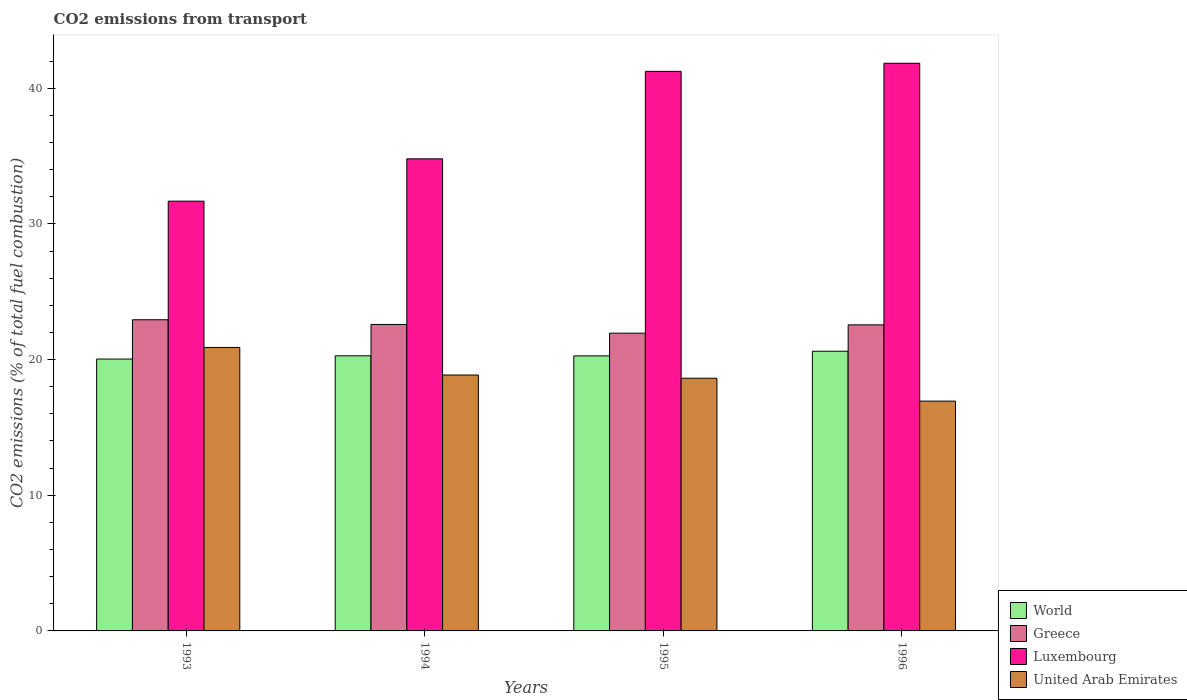Are the number of bars on each tick of the X-axis equal?
Make the answer very short. Yes. How many bars are there on the 4th tick from the left?
Give a very brief answer. 4. In how many cases, is the number of bars for a given year not equal to the number of legend labels?
Give a very brief answer. 0. What is the total CO2 emitted in World in 1993?
Give a very brief answer. 20.04. Across all years, what is the maximum total CO2 emitted in Greece?
Provide a succinct answer. 22.94. Across all years, what is the minimum total CO2 emitted in Luxembourg?
Keep it short and to the point. 31.68. In which year was the total CO2 emitted in World minimum?
Provide a short and direct response. 1993. What is the total total CO2 emitted in Greece in the graph?
Your answer should be compact. 90.03. What is the difference between the total CO2 emitted in World in 1994 and that in 1996?
Keep it short and to the point. -0.34. What is the difference between the total CO2 emitted in United Arab Emirates in 1993 and the total CO2 emitted in Greece in 1995?
Offer a very short reply. -1.06. What is the average total CO2 emitted in Luxembourg per year?
Your response must be concise. 37.39. In the year 1995, what is the difference between the total CO2 emitted in Luxembourg and total CO2 emitted in United Arab Emirates?
Your answer should be very brief. 22.62. What is the ratio of the total CO2 emitted in Greece in 1995 to that in 1996?
Provide a succinct answer. 0.97. Is the total CO2 emitted in Luxembourg in 1993 less than that in 1994?
Provide a succinct answer. Yes. What is the difference between the highest and the second highest total CO2 emitted in World?
Provide a succinct answer. 0.34. What is the difference between the highest and the lowest total CO2 emitted in Luxembourg?
Your response must be concise. 10.16. In how many years, is the total CO2 emitted in Greece greater than the average total CO2 emitted in Greece taken over all years?
Keep it short and to the point. 3. Is the sum of the total CO2 emitted in World in 1994 and 1995 greater than the maximum total CO2 emitted in Greece across all years?
Make the answer very short. Yes. What does the 2nd bar from the right in 1995 represents?
Keep it short and to the point. Luxembourg. How many bars are there?
Give a very brief answer. 16. Are all the bars in the graph horizontal?
Your answer should be very brief. No. How many years are there in the graph?
Provide a short and direct response. 4. Are the values on the major ticks of Y-axis written in scientific E-notation?
Your answer should be very brief. No. Does the graph contain any zero values?
Provide a short and direct response. No. Where does the legend appear in the graph?
Provide a short and direct response. Bottom right. What is the title of the graph?
Give a very brief answer. CO2 emissions from transport. Does "Romania" appear as one of the legend labels in the graph?
Your response must be concise. No. What is the label or title of the X-axis?
Make the answer very short. Years. What is the label or title of the Y-axis?
Provide a succinct answer. CO2 emissions (% of total fuel combustion). What is the CO2 emissions (% of total fuel combustion) in World in 1993?
Offer a very short reply. 20.04. What is the CO2 emissions (% of total fuel combustion) of Greece in 1993?
Make the answer very short. 22.94. What is the CO2 emissions (% of total fuel combustion) in Luxembourg in 1993?
Provide a succinct answer. 31.68. What is the CO2 emissions (% of total fuel combustion) in United Arab Emirates in 1993?
Your answer should be compact. 20.89. What is the CO2 emissions (% of total fuel combustion) in World in 1994?
Make the answer very short. 20.28. What is the CO2 emissions (% of total fuel combustion) in Greece in 1994?
Give a very brief answer. 22.59. What is the CO2 emissions (% of total fuel combustion) of Luxembourg in 1994?
Make the answer very short. 34.8. What is the CO2 emissions (% of total fuel combustion) in United Arab Emirates in 1994?
Provide a succinct answer. 18.86. What is the CO2 emissions (% of total fuel combustion) in World in 1995?
Keep it short and to the point. 20.27. What is the CO2 emissions (% of total fuel combustion) of Greece in 1995?
Give a very brief answer. 21.95. What is the CO2 emissions (% of total fuel combustion) of Luxembourg in 1995?
Offer a terse response. 41.24. What is the CO2 emissions (% of total fuel combustion) in United Arab Emirates in 1995?
Offer a terse response. 18.62. What is the CO2 emissions (% of total fuel combustion) in World in 1996?
Offer a terse response. 20.61. What is the CO2 emissions (% of total fuel combustion) in Greece in 1996?
Ensure brevity in your answer.  22.56. What is the CO2 emissions (% of total fuel combustion) in Luxembourg in 1996?
Offer a very short reply. 41.84. What is the CO2 emissions (% of total fuel combustion) in United Arab Emirates in 1996?
Offer a terse response. 16.94. Across all years, what is the maximum CO2 emissions (% of total fuel combustion) in World?
Give a very brief answer. 20.61. Across all years, what is the maximum CO2 emissions (% of total fuel combustion) in Greece?
Ensure brevity in your answer.  22.94. Across all years, what is the maximum CO2 emissions (% of total fuel combustion) of Luxembourg?
Provide a short and direct response. 41.84. Across all years, what is the maximum CO2 emissions (% of total fuel combustion) of United Arab Emirates?
Make the answer very short. 20.89. Across all years, what is the minimum CO2 emissions (% of total fuel combustion) in World?
Ensure brevity in your answer.  20.04. Across all years, what is the minimum CO2 emissions (% of total fuel combustion) of Greece?
Make the answer very short. 21.95. Across all years, what is the minimum CO2 emissions (% of total fuel combustion) of Luxembourg?
Offer a very short reply. 31.68. Across all years, what is the minimum CO2 emissions (% of total fuel combustion) of United Arab Emirates?
Make the answer very short. 16.94. What is the total CO2 emissions (% of total fuel combustion) in World in the graph?
Make the answer very short. 81.2. What is the total CO2 emissions (% of total fuel combustion) of Greece in the graph?
Keep it short and to the point. 90.03. What is the total CO2 emissions (% of total fuel combustion) of Luxembourg in the graph?
Ensure brevity in your answer.  149.55. What is the total CO2 emissions (% of total fuel combustion) in United Arab Emirates in the graph?
Give a very brief answer. 75.31. What is the difference between the CO2 emissions (% of total fuel combustion) in World in 1993 and that in 1994?
Offer a very short reply. -0.24. What is the difference between the CO2 emissions (% of total fuel combustion) of Greece in 1993 and that in 1994?
Your answer should be very brief. 0.35. What is the difference between the CO2 emissions (% of total fuel combustion) in Luxembourg in 1993 and that in 1994?
Make the answer very short. -3.12. What is the difference between the CO2 emissions (% of total fuel combustion) of United Arab Emirates in 1993 and that in 1994?
Your answer should be very brief. 2.03. What is the difference between the CO2 emissions (% of total fuel combustion) of World in 1993 and that in 1995?
Provide a succinct answer. -0.23. What is the difference between the CO2 emissions (% of total fuel combustion) in Greece in 1993 and that in 1995?
Ensure brevity in your answer.  0.99. What is the difference between the CO2 emissions (% of total fuel combustion) in Luxembourg in 1993 and that in 1995?
Your answer should be compact. -9.57. What is the difference between the CO2 emissions (% of total fuel combustion) in United Arab Emirates in 1993 and that in 1995?
Provide a succinct answer. 2.27. What is the difference between the CO2 emissions (% of total fuel combustion) in World in 1993 and that in 1996?
Offer a terse response. -0.58. What is the difference between the CO2 emissions (% of total fuel combustion) of Greece in 1993 and that in 1996?
Your answer should be compact. 0.38. What is the difference between the CO2 emissions (% of total fuel combustion) of Luxembourg in 1993 and that in 1996?
Ensure brevity in your answer.  -10.16. What is the difference between the CO2 emissions (% of total fuel combustion) in United Arab Emirates in 1993 and that in 1996?
Provide a succinct answer. 3.95. What is the difference between the CO2 emissions (% of total fuel combustion) in World in 1994 and that in 1995?
Your response must be concise. 0.01. What is the difference between the CO2 emissions (% of total fuel combustion) in Greece in 1994 and that in 1995?
Provide a succinct answer. 0.64. What is the difference between the CO2 emissions (% of total fuel combustion) of Luxembourg in 1994 and that in 1995?
Your response must be concise. -6.45. What is the difference between the CO2 emissions (% of total fuel combustion) of United Arab Emirates in 1994 and that in 1995?
Give a very brief answer. 0.24. What is the difference between the CO2 emissions (% of total fuel combustion) of World in 1994 and that in 1996?
Your response must be concise. -0.34. What is the difference between the CO2 emissions (% of total fuel combustion) in Greece in 1994 and that in 1996?
Provide a succinct answer. 0.03. What is the difference between the CO2 emissions (% of total fuel combustion) in Luxembourg in 1994 and that in 1996?
Your answer should be very brief. -7.04. What is the difference between the CO2 emissions (% of total fuel combustion) of United Arab Emirates in 1994 and that in 1996?
Provide a succinct answer. 1.92. What is the difference between the CO2 emissions (% of total fuel combustion) in World in 1995 and that in 1996?
Ensure brevity in your answer.  -0.34. What is the difference between the CO2 emissions (% of total fuel combustion) of Greece in 1995 and that in 1996?
Give a very brief answer. -0.61. What is the difference between the CO2 emissions (% of total fuel combustion) of Luxembourg in 1995 and that in 1996?
Keep it short and to the point. -0.6. What is the difference between the CO2 emissions (% of total fuel combustion) in United Arab Emirates in 1995 and that in 1996?
Provide a short and direct response. 1.69. What is the difference between the CO2 emissions (% of total fuel combustion) in World in 1993 and the CO2 emissions (% of total fuel combustion) in Greece in 1994?
Your response must be concise. -2.55. What is the difference between the CO2 emissions (% of total fuel combustion) of World in 1993 and the CO2 emissions (% of total fuel combustion) of Luxembourg in 1994?
Give a very brief answer. -14.76. What is the difference between the CO2 emissions (% of total fuel combustion) in World in 1993 and the CO2 emissions (% of total fuel combustion) in United Arab Emirates in 1994?
Provide a succinct answer. 1.18. What is the difference between the CO2 emissions (% of total fuel combustion) of Greece in 1993 and the CO2 emissions (% of total fuel combustion) of Luxembourg in 1994?
Ensure brevity in your answer.  -11.86. What is the difference between the CO2 emissions (% of total fuel combustion) of Greece in 1993 and the CO2 emissions (% of total fuel combustion) of United Arab Emirates in 1994?
Make the answer very short. 4.07. What is the difference between the CO2 emissions (% of total fuel combustion) in Luxembourg in 1993 and the CO2 emissions (% of total fuel combustion) in United Arab Emirates in 1994?
Ensure brevity in your answer.  12.81. What is the difference between the CO2 emissions (% of total fuel combustion) of World in 1993 and the CO2 emissions (% of total fuel combustion) of Greece in 1995?
Provide a short and direct response. -1.91. What is the difference between the CO2 emissions (% of total fuel combustion) in World in 1993 and the CO2 emissions (% of total fuel combustion) in Luxembourg in 1995?
Your answer should be compact. -21.2. What is the difference between the CO2 emissions (% of total fuel combustion) in World in 1993 and the CO2 emissions (% of total fuel combustion) in United Arab Emirates in 1995?
Make the answer very short. 1.41. What is the difference between the CO2 emissions (% of total fuel combustion) in Greece in 1993 and the CO2 emissions (% of total fuel combustion) in Luxembourg in 1995?
Make the answer very short. -18.31. What is the difference between the CO2 emissions (% of total fuel combustion) of Greece in 1993 and the CO2 emissions (% of total fuel combustion) of United Arab Emirates in 1995?
Offer a very short reply. 4.31. What is the difference between the CO2 emissions (% of total fuel combustion) in Luxembourg in 1993 and the CO2 emissions (% of total fuel combustion) in United Arab Emirates in 1995?
Keep it short and to the point. 13.05. What is the difference between the CO2 emissions (% of total fuel combustion) in World in 1993 and the CO2 emissions (% of total fuel combustion) in Greece in 1996?
Your response must be concise. -2.52. What is the difference between the CO2 emissions (% of total fuel combustion) in World in 1993 and the CO2 emissions (% of total fuel combustion) in Luxembourg in 1996?
Make the answer very short. -21.8. What is the difference between the CO2 emissions (% of total fuel combustion) of World in 1993 and the CO2 emissions (% of total fuel combustion) of United Arab Emirates in 1996?
Offer a very short reply. 3.1. What is the difference between the CO2 emissions (% of total fuel combustion) in Greece in 1993 and the CO2 emissions (% of total fuel combustion) in Luxembourg in 1996?
Give a very brief answer. -18.91. What is the difference between the CO2 emissions (% of total fuel combustion) of Greece in 1993 and the CO2 emissions (% of total fuel combustion) of United Arab Emirates in 1996?
Give a very brief answer. 6. What is the difference between the CO2 emissions (% of total fuel combustion) in Luxembourg in 1993 and the CO2 emissions (% of total fuel combustion) in United Arab Emirates in 1996?
Keep it short and to the point. 14.74. What is the difference between the CO2 emissions (% of total fuel combustion) in World in 1994 and the CO2 emissions (% of total fuel combustion) in Greece in 1995?
Make the answer very short. -1.67. What is the difference between the CO2 emissions (% of total fuel combustion) of World in 1994 and the CO2 emissions (% of total fuel combustion) of Luxembourg in 1995?
Offer a terse response. -20.96. What is the difference between the CO2 emissions (% of total fuel combustion) in World in 1994 and the CO2 emissions (% of total fuel combustion) in United Arab Emirates in 1995?
Your answer should be very brief. 1.65. What is the difference between the CO2 emissions (% of total fuel combustion) of Greece in 1994 and the CO2 emissions (% of total fuel combustion) of Luxembourg in 1995?
Make the answer very short. -18.65. What is the difference between the CO2 emissions (% of total fuel combustion) in Greece in 1994 and the CO2 emissions (% of total fuel combustion) in United Arab Emirates in 1995?
Offer a very short reply. 3.96. What is the difference between the CO2 emissions (% of total fuel combustion) in Luxembourg in 1994 and the CO2 emissions (% of total fuel combustion) in United Arab Emirates in 1995?
Offer a terse response. 16.17. What is the difference between the CO2 emissions (% of total fuel combustion) in World in 1994 and the CO2 emissions (% of total fuel combustion) in Greece in 1996?
Give a very brief answer. -2.28. What is the difference between the CO2 emissions (% of total fuel combustion) of World in 1994 and the CO2 emissions (% of total fuel combustion) of Luxembourg in 1996?
Your answer should be compact. -21.56. What is the difference between the CO2 emissions (% of total fuel combustion) in World in 1994 and the CO2 emissions (% of total fuel combustion) in United Arab Emirates in 1996?
Make the answer very short. 3.34. What is the difference between the CO2 emissions (% of total fuel combustion) of Greece in 1994 and the CO2 emissions (% of total fuel combustion) of Luxembourg in 1996?
Keep it short and to the point. -19.25. What is the difference between the CO2 emissions (% of total fuel combustion) in Greece in 1994 and the CO2 emissions (% of total fuel combustion) in United Arab Emirates in 1996?
Your answer should be very brief. 5.65. What is the difference between the CO2 emissions (% of total fuel combustion) in Luxembourg in 1994 and the CO2 emissions (% of total fuel combustion) in United Arab Emirates in 1996?
Keep it short and to the point. 17.86. What is the difference between the CO2 emissions (% of total fuel combustion) of World in 1995 and the CO2 emissions (% of total fuel combustion) of Greece in 1996?
Offer a very short reply. -2.29. What is the difference between the CO2 emissions (% of total fuel combustion) in World in 1995 and the CO2 emissions (% of total fuel combustion) in Luxembourg in 1996?
Offer a very short reply. -21.57. What is the difference between the CO2 emissions (% of total fuel combustion) of World in 1995 and the CO2 emissions (% of total fuel combustion) of United Arab Emirates in 1996?
Your answer should be compact. 3.33. What is the difference between the CO2 emissions (% of total fuel combustion) of Greece in 1995 and the CO2 emissions (% of total fuel combustion) of Luxembourg in 1996?
Your answer should be very brief. -19.89. What is the difference between the CO2 emissions (% of total fuel combustion) in Greece in 1995 and the CO2 emissions (% of total fuel combustion) in United Arab Emirates in 1996?
Provide a succinct answer. 5.01. What is the difference between the CO2 emissions (% of total fuel combustion) of Luxembourg in 1995 and the CO2 emissions (% of total fuel combustion) of United Arab Emirates in 1996?
Offer a very short reply. 24.3. What is the average CO2 emissions (% of total fuel combustion) in World per year?
Your answer should be compact. 20.3. What is the average CO2 emissions (% of total fuel combustion) in Greece per year?
Your response must be concise. 22.51. What is the average CO2 emissions (% of total fuel combustion) of Luxembourg per year?
Provide a succinct answer. 37.39. What is the average CO2 emissions (% of total fuel combustion) of United Arab Emirates per year?
Ensure brevity in your answer.  18.83. In the year 1993, what is the difference between the CO2 emissions (% of total fuel combustion) in World and CO2 emissions (% of total fuel combustion) in Greece?
Offer a very short reply. -2.9. In the year 1993, what is the difference between the CO2 emissions (% of total fuel combustion) of World and CO2 emissions (% of total fuel combustion) of Luxembourg?
Keep it short and to the point. -11.64. In the year 1993, what is the difference between the CO2 emissions (% of total fuel combustion) in World and CO2 emissions (% of total fuel combustion) in United Arab Emirates?
Your answer should be compact. -0.85. In the year 1993, what is the difference between the CO2 emissions (% of total fuel combustion) of Greece and CO2 emissions (% of total fuel combustion) of Luxembourg?
Your answer should be very brief. -8.74. In the year 1993, what is the difference between the CO2 emissions (% of total fuel combustion) of Greece and CO2 emissions (% of total fuel combustion) of United Arab Emirates?
Ensure brevity in your answer.  2.04. In the year 1993, what is the difference between the CO2 emissions (% of total fuel combustion) in Luxembourg and CO2 emissions (% of total fuel combustion) in United Arab Emirates?
Offer a terse response. 10.78. In the year 1994, what is the difference between the CO2 emissions (% of total fuel combustion) in World and CO2 emissions (% of total fuel combustion) in Greece?
Give a very brief answer. -2.31. In the year 1994, what is the difference between the CO2 emissions (% of total fuel combustion) of World and CO2 emissions (% of total fuel combustion) of Luxembourg?
Offer a very short reply. -14.52. In the year 1994, what is the difference between the CO2 emissions (% of total fuel combustion) of World and CO2 emissions (% of total fuel combustion) of United Arab Emirates?
Ensure brevity in your answer.  1.42. In the year 1994, what is the difference between the CO2 emissions (% of total fuel combustion) in Greece and CO2 emissions (% of total fuel combustion) in Luxembourg?
Your response must be concise. -12.21. In the year 1994, what is the difference between the CO2 emissions (% of total fuel combustion) in Greece and CO2 emissions (% of total fuel combustion) in United Arab Emirates?
Make the answer very short. 3.73. In the year 1994, what is the difference between the CO2 emissions (% of total fuel combustion) of Luxembourg and CO2 emissions (% of total fuel combustion) of United Arab Emirates?
Your response must be concise. 15.93. In the year 1995, what is the difference between the CO2 emissions (% of total fuel combustion) of World and CO2 emissions (% of total fuel combustion) of Greece?
Your answer should be compact. -1.67. In the year 1995, what is the difference between the CO2 emissions (% of total fuel combustion) of World and CO2 emissions (% of total fuel combustion) of Luxembourg?
Offer a very short reply. -20.97. In the year 1995, what is the difference between the CO2 emissions (% of total fuel combustion) of World and CO2 emissions (% of total fuel combustion) of United Arab Emirates?
Offer a terse response. 1.65. In the year 1995, what is the difference between the CO2 emissions (% of total fuel combustion) of Greece and CO2 emissions (% of total fuel combustion) of Luxembourg?
Offer a very short reply. -19.3. In the year 1995, what is the difference between the CO2 emissions (% of total fuel combustion) of Greece and CO2 emissions (% of total fuel combustion) of United Arab Emirates?
Make the answer very short. 3.32. In the year 1995, what is the difference between the CO2 emissions (% of total fuel combustion) in Luxembourg and CO2 emissions (% of total fuel combustion) in United Arab Emirates?
Ensure brevity in your answer.  22.62. In the year 1996, what is the difference between the CO2 emissions (% of total fuel combustion) of World and CO2 emissions (% of total fuel combustion) of Greece?
Your answer should be compact. -1.94. In the year 1996, what is the difference between the CO2 emissions (% of total fuel combustion) of World and CO2 emissions (% of total fuel combustion) of Luxembourg?
Offer a terse response. -21.23. In the year 1996, what is the difference between the CO2 emissions (% of total fuel combustion) of World and CO2 emissions (% of total fuel combustion) of United Arab Emirates?
Provide a short and direct response. 3.68. In the year 1996, what is the difference between the CO2 emissions (% of total fuel combustion) of Greece and CO2 emissions (% of total fuel combustion) of Luxembourg?
Your response must be concise. -19.28. In the year 1996, what is the difference between the CO2 emissions (% of total fuel combustion) of Greece and CO2 emissions (% of total fuel combustion) of United Arab Emirates?
Your answer should be compact. 5.62. In the year 1996, what is the difference between the CO2 emissions (% of total fuel combustion) in Luxembourg and CO2 emissions (% of total fuel combustion) in United Arab Emirates?
Give a very brief answer. 24.9. What is the ratio of the CO2 emissions (% of total fuel combustion) of Greece in 1993 to that in 1994?
Ensure brevity in your answer.  1.02. What is the ratio of the CO2 emissions (% of total fuel combustion) of Luxembourg in 1993 to that in 1994?
Offer a very short reply. 0.91. What is the ratio of the CO2 emissions (% of total fuel combustion) of United Arab Emirates in 1993 to that in 1994?
Keep it short and to the point. 1.11. What is the ratio of the CO2 emissions (% of total fuel combustion) of World in 1993 to that in 1995?
Your answer should be compact. 0.99. What is the ratio of the CO2 emissions (% of total fuel combustion) in Greece in 1993 to that in 1995?
Ensure brevity in your answer.  1.04. What is the ratio of the CO2 emissions (% of total fuel combustion) in Luxembourg in 1993 to that in 1995?
Provide a succinct answer. 0.77. What is the ratio of the CO2 emissions (% of total fuel combustion) in United Arab Emirates in 1993 to that in 1995?
Offer a terse response. 1.12. What is the ratio of the CO2 emissions (% of total fuel combustion) of World in 1993 to that in 1996?
Your response must be concise. 0.97. What is the ratio of the CO2 emissions (% of total fuel combustion) of Greece in 1993 to that in 1996?
Your answer should be compact. 1.02. What is the ratio of the CO2 emissions (% of total fuel combustion) in Luxembourg in 1993 to that in 1996?
Offer a very short reply. 0.76. What is the ratio of the CO2 emissions (% of total fuel combustion) in United Arab Emirates in 1993 to that in 1996?
Your response must be concise. 1.23. What is the ratio of the CO2 emissions (% of total fuel combustion) in Greece in 1994 to that in 1995?
Your answer should be very brief. 1.03. What is the ratio of the CO2 emissions (% of total fuel combustion) of Luxembourg in 1994 to that in 1995?
Ensure brevity in your answer.  0.84. What is the ratio of the CO2 emissions (% of total fuel combustion) of United Arab Emirates in 1994 to that in 1995?
Offer a very short reply. 1.01. What is the ratio of the CO2 emissions (% of total fuel combustion) in World in 1994 to that in 1996?
Your answer should be compact. 0.98. What is the ratio of the CO2 emissions (% of total fuel combustion) of Luxembourg in 1994 to that in 1996?
Provide a short and direct response. 0.83. What is the ratio of the CO2 emissions (% of total fuel combustion) of United Arab Emirates in 1994 to that in 1996?
Your response must be concise. 1.11. What is the ratio of the CO2 emissions (% of total fuel combustion) of World in 1995 to that in 1996?
Give a very brief answer. 0.98. What is the ratio of the CO2 emissions (% of total fuel combustion) in Greece in 1995 to that in 1996?
Provide a succinct answer. 0.97. What is the ratio of the CO2 emissions (% of total fuel combustion) of Luxembourg in 1995 to that in 1996?
Offer a terse response. 0.99. What is the ratio of the CO2 emissions (% of total fuel combustion) in United Arab Emirates in 1995 to that in 1996?
Offer a very short reply. 1.1. What is the difference between the highest and the second highest CO2 emissions (% of total fuel combustion) in World?
Your answer should be very brief. 0.34. What is the difference between the highest and the second highest CO2 emissions (% of total fuel combustion) of Greece?
Give a very brief answer. 0.35. What is the difference between the highest and the second highest CO2 emissions (% of total fuel combustion) of Luxembourg?
Offer a very short reply. 0.6. What is the difference between the highest and the second highest CO2 emissions (% of total fuel combustion) in United Arab Emirates?
Make the answer very short. 2.03. What is the difference between the highest and the lowest CO2 emissions (% of total fuel combustion) of World?
Provide a short and direct response. 0.58. What is the difference between the highest and the lowest CO2 emissions (% of total fuel combustion) in Luxembourg?
Offer a terse response. 10.16. What is the difference between the highest and the lowest CO2 emissions (% of total fuel combustion) in United Arab Emirates?
Give a very brief answer. 3.95. 